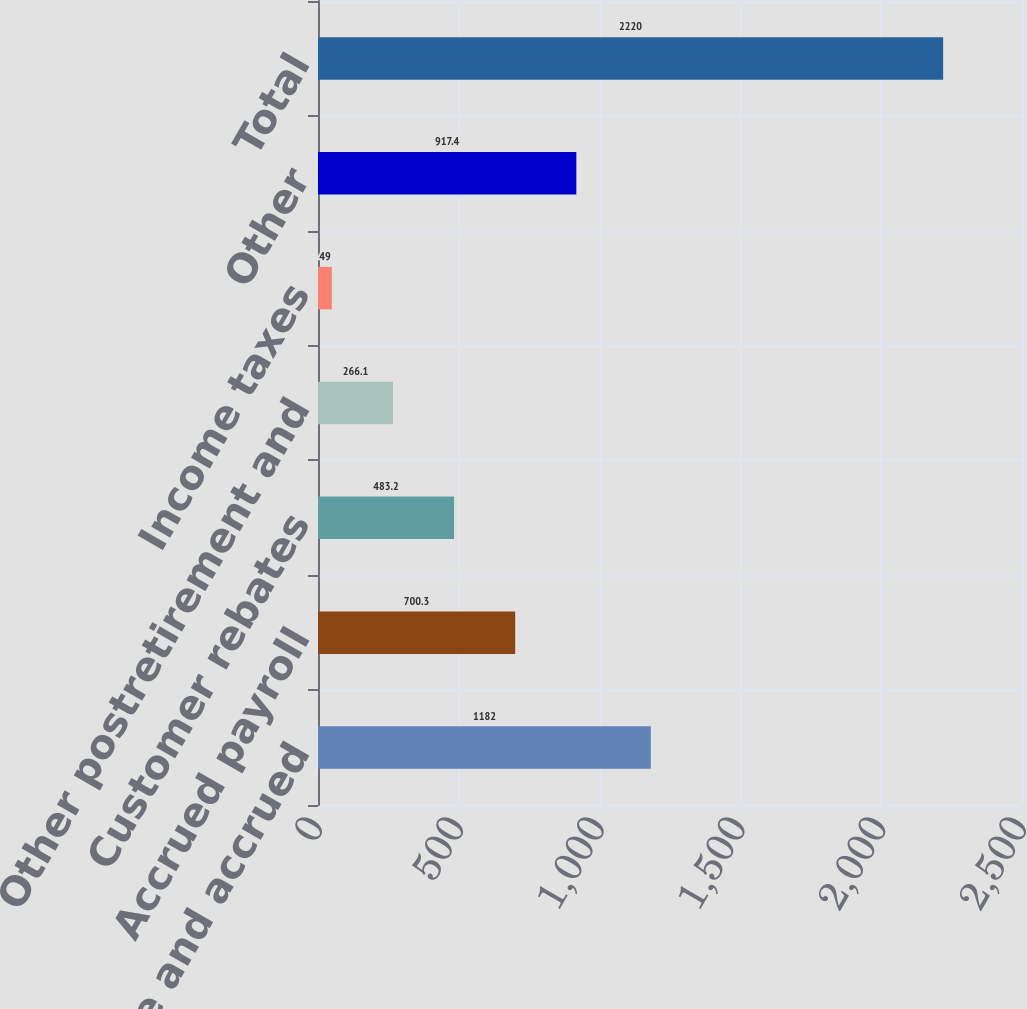<chart> <loc_0><loc_0><loc_500><loc_500><bar_chart><fcel>Accounts payable and accrued<fcel>Accrued payroll<fcel>Customer rebates<fcel>Other postretirement and<fcel>Income taxes<fcel>Other<fcel>Total<nl><fcel>1182<fcel>700.3<fcel>483.2<fcel>266.1<fcel>49<fcel>917.4<fcel>2220<nl></chart> 